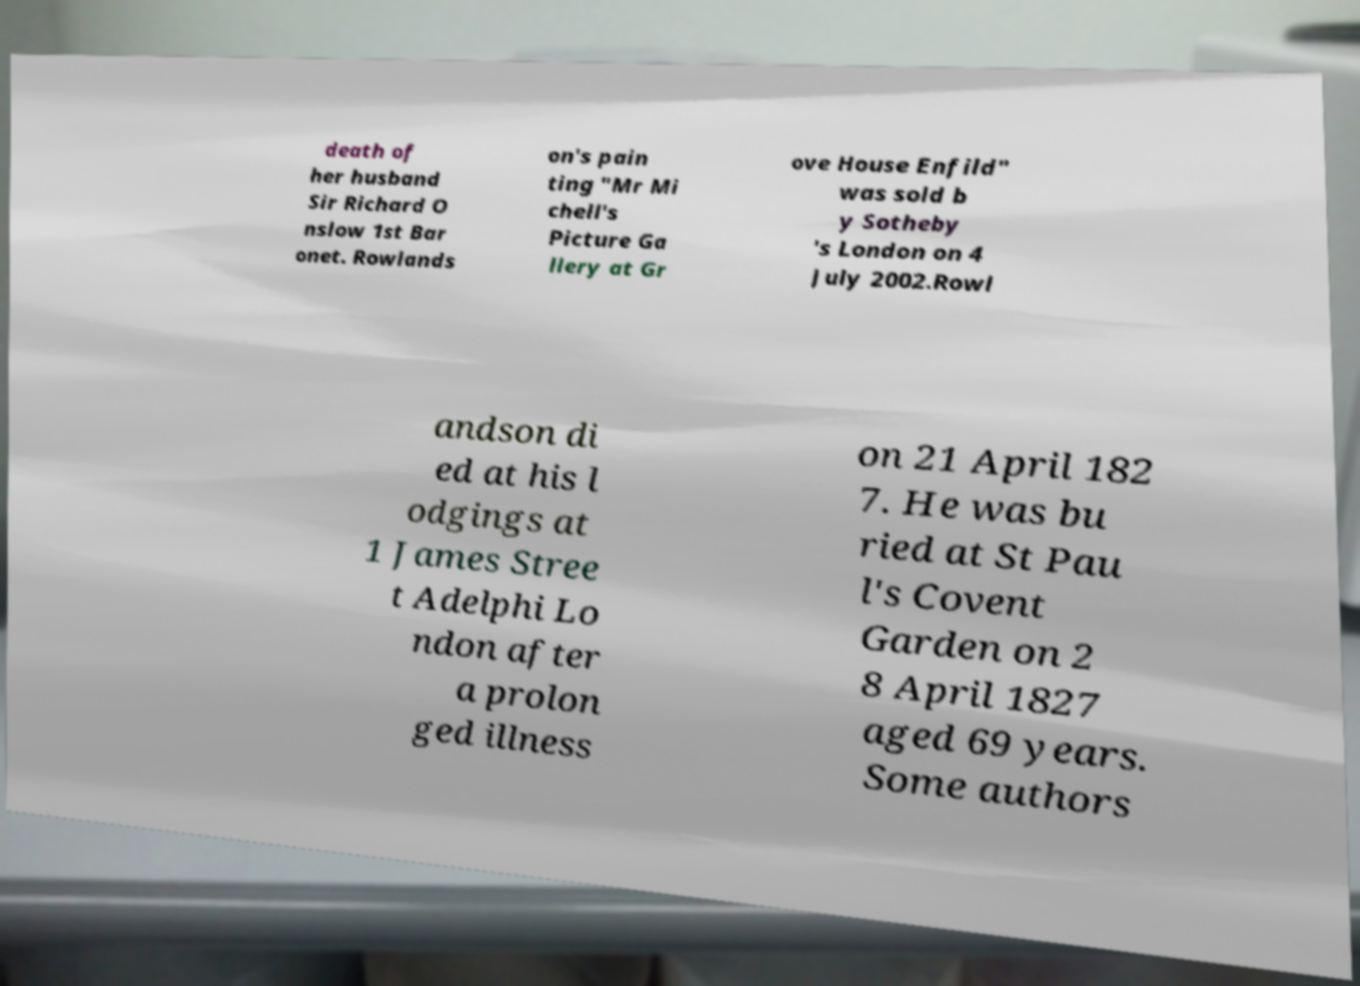What messages or text are displayed in this image? I need them in a readable, typed format. death of her husband Sir Richard O nslow 1st Bar onet. Rowlands on's pain ting "Mr Mi chell's Picture Ga llery at Gr ove House Enfild" was sold b y Sotheby 's London on 4 July 2002.Rowl andson di ed at his l odgings at 1 James Stree t Adelphi Lo ndon after a prolon ged illness on 21 April 182 7. He was bu ried at St Pau l's Covent Garden on 2 8 April 1827 aged 69 years. Some authors 